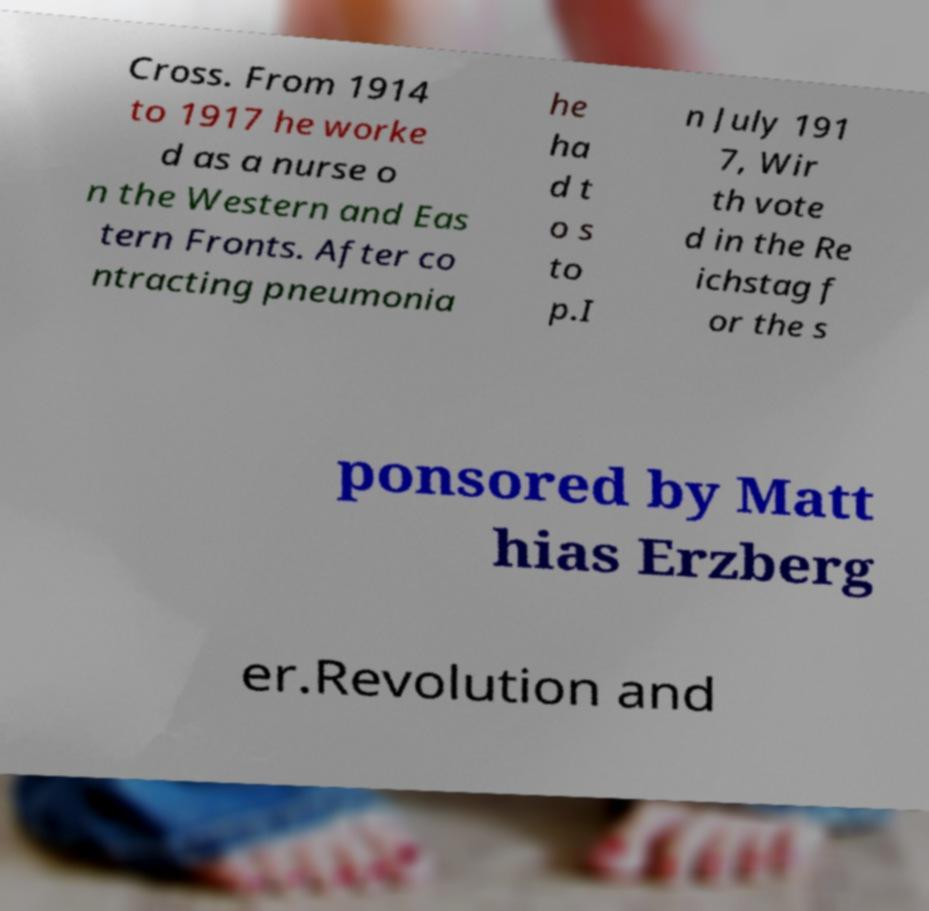Can you accurately transcribe the text from the provided image for me? Cross. From 1914 to 1917 he worke d as a nurse o n the Western and Eas tern Fronts. After co ntracting pneumonia he ha d t o s to p.I n July 191 7, Wir th vote d in the Re ichstag f or the s ponsored by Matt hias Erzberg er.Revolution and 